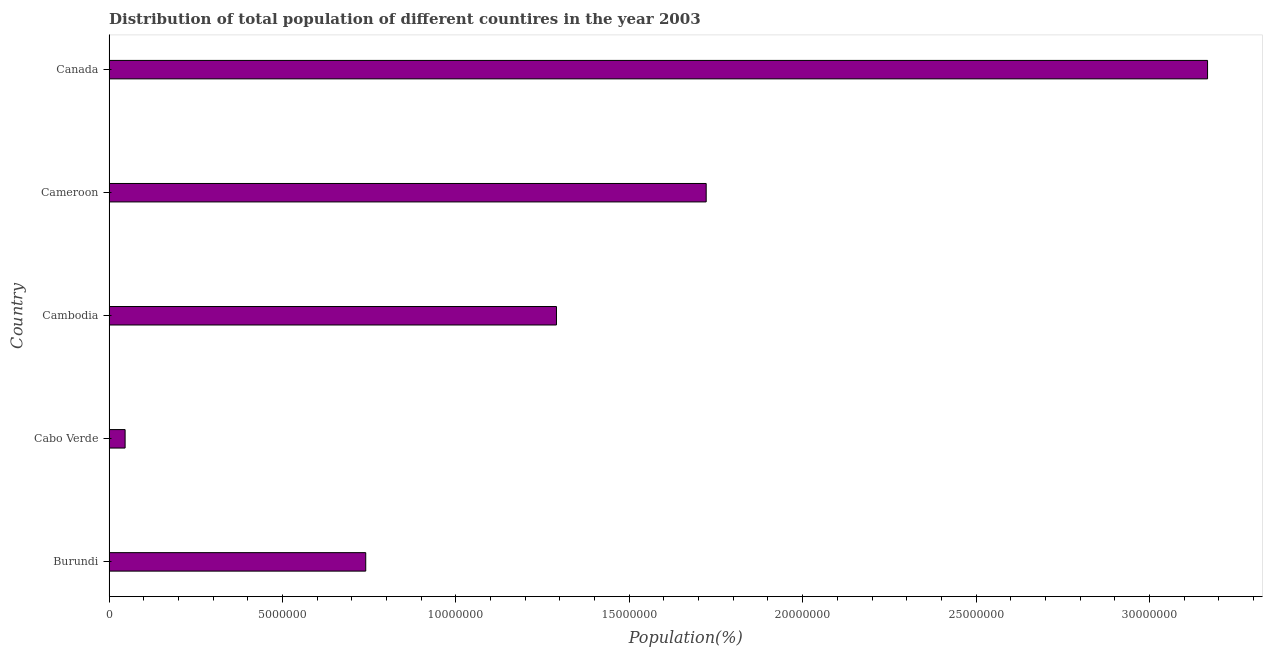What is the title of the graph?
Offer a very short reply. Distribution of total population of different countires in the year 2003. What is the label or title of the X-axis?
Provide a short and direct response. Population(%). What is the label or title of the Y-axis?
Give a very brief answer. Country. What is the population in Burundi?
Provide a short and direct response. 7.40e+06. Across all countries, what is the maximum population?
Your response must be concise. 3.17e+07. Across all countries, what is the minimum population?
Provide a succinct answer. 4.63e+05. In which country was the population minimum?
Provide a short and direct response. Cabo Verde. What is the sum of the population?
Your answer should be very brief. 6.97e+07. What is the difference between the population in Cameroon and Canada?
Make the answer very short. -1.45e+07. What is the average population per country?
Make the answer very short. 1.39e+07. What is the median population?
Make the answer very short. 1.29e+07. In how many countries, is the population greater than 4000000 %?
Offer a terse response. 4. What is the ratio of the population in Cabo Verde to that in Cambodia?
Ensure brevity in your answer.  0.04. Is the population in Cameroon less than that in Canada?
Your response must be concise. Yes. Is the difference between the population in Cabo Verde and Cameroon greater than the difference between any two countries?
Give a very brief answer. No. What is the difference between the highest and the second highest population?
Give a very brief answer. 1.45e+07. What is the difference between the highest and the lowest population?
Provide a short and direct response. 3.12e+07. How many countries are there in the graph?
Your answer should be very brief. 5. What is the difference between two consecutive major ticks on the X-axis?
Provide a short and direct response. 5.00e+06. Are the values on the major ticks of X-axis written in scientific E-notation?
Ensure brevity in your answer.  No. What is the Population(%) in Burundi?
Your answer should be very brief. 7.40e+06. What is the Population(%) in Cabo Verde?
Your answer should be very brief. 4.63e+05. What is the Population(%) in Cambodia?
Provide a short and direct response. 1.29e+07. What is the Population(%) of Cameroon?
Provide a short and direct response. 1.72e+07. What is the Population(%) of Canada?
Make the answer very short. 3.17e+07. What is the difference between the Population(%) in Burundi and Cabo Verde?
Your answer should be very brief. 6.94e+06. What is the difference between the Population(%) in Burundi and Cambodia?
Ensure brevity in your answer.  -5.50e+06. What is the difference between the Population(%) in Burundi and Cameroon?
Offer a terse response. -9.82e+06. What is the difference between the Population(%) in Burundi and Canada?
Your answer should be compact. -2.43e+07. What is the difference between the Population(%) in Cabo Verde and Cambodia?
Offer a very short reply. -1.24e+07. What is the difference between the Population(%) in Cabo Verde and Cameroon?
Offer a terse response. -1.68e+07. What is the difference between the Population(%) in Cabo Verde and Canada?
Your response must be concise. -3.12e+07. What is the difference between the Population(%) in Cambodia and Cameroon?
Provide a succinct answer. -4.32e+06. What is the difference between the Population(%) in Cambodia and Canada?
Provide a succinct answer. -1.88e+07. What is the difference between the Population(%) in Cameroon and Canada?
Provide a succinct answer. -1.45e+07. What is the ratio of the Population(%) in Burundi to that in Cabo Verde?
Provide a succinct answer. 16. What is the ratio of the Population(%) in Burundi to that in Cambodia?
Your answer should be compact. 0.57. What is the ratio of the Population(%) in Burundi to that in Cameroon?
Offer a terse response. 0.43. What is the ratio of the Population(%) in Burundi to that in Canada?
Offer a very short reply. 0.23. What is the ratio of the Population(%) in Cabo Verde to that in Cambodia?
Give a very brief answer. 0.04. What is the ratio of the Population(%) in Cabo Verde to that in Cameroon?
Ensure brevity in your answer.  0.03. What is the ratio of the Population(%) in Cabo Verde to that in Canada?
Your answer should be compact. 0.01. What is the ratio of the Population(%) in Cambodia to that in Cameroon?
Your response must be concise. 0.75. What is the ratio of the Population(%) in Cambodia to that in Canada?
Your answer should be very brief. 0.41. What is the ratio of the Population(%) in Cameroon to that in Canada?
Give a very brief answer. 0.54. 